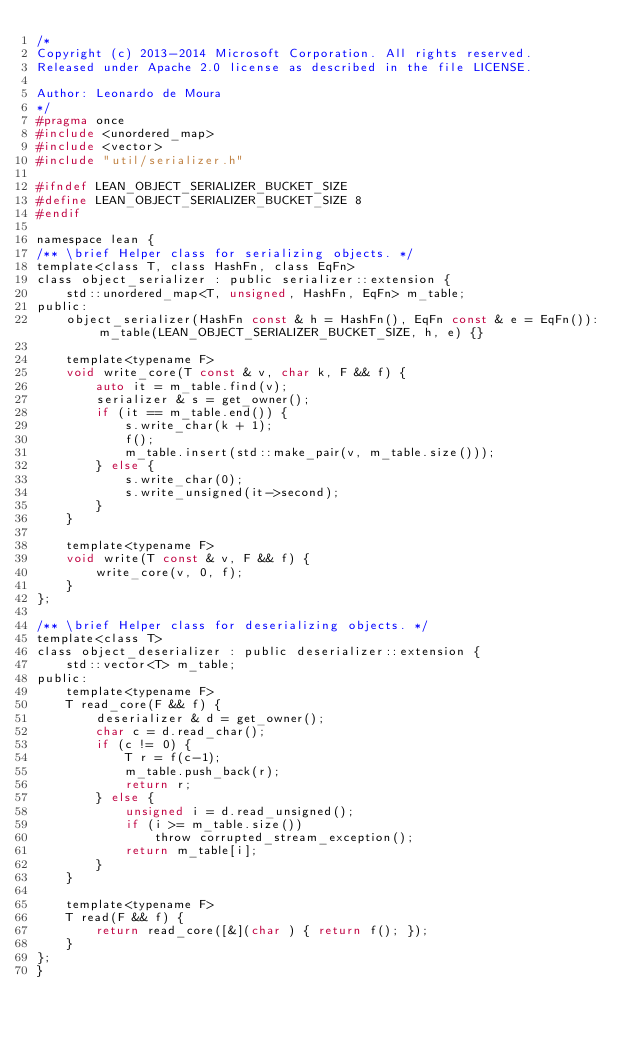Convert code to text. <code><loc_0><loc_0><loc_500><loc_500><_C_>/*
Copyright (c) 2013-2014 Microsoft Corporation. All rights reserved.
Released under Apache 2.0 license as described in the file LICENSE.

Author: Leonardo de Moura
*/
#pragma once
#include <unordered_map>
#include <vector>
#include "util/serializer.h"

#ifndef LEAN_OBJECT_SERIALIZER_BUCKET_SIZE
#define LEAN_OBJECT_SERIALIZER_BUCKET_SIZE 8
#endif

namespace lean {
/** \brief Helper class for serializing objects. */
template<class T, class HashFn, class EqFn>
class object_serializer : public serializer::extension {
    std::unordered_map<T, unsigned, HashFn, EqFn> m_table;
public:
    object_serializer(HashFn const & h = HashFn(), EqFn const & e = EqFn()):m_table(LEAN_OBJECT_SERIALIZER_BUCKET_SIZE, h, e) {}

    template<typename F>
    void write_core(T const & v, char k, F && f) {
        auto it = m_table.find(v);
        serializer & s = get_owner();
        if (it == m_table.end()) {
            s.write_char(k + 1);
            f();
            m_table.insert(std::make_pair(v, m_table.size()));
        } else {
            s.write_char(0);
            s.write_unsigned(it->second);
        }
    }

    template<typename F>
    void write(T const & v, F && f) {
        write_core(v, 0, f);
    }
};

/** \brief Helper class for deserializing objects. */
template<class T>
class object_deserializer : public deserializer::extension {
    std::vector<T> m_table;
public:
    template<typename F>
    T read_core(F && f) {
        deserializer & d = get_owner();
        char c = d.read_char();
        if (c != 0) {
            T r = f(c-1);
            m_table.push_back(r);
            return r;
        } else {
            unsigned i = d.read_unsigned();
            if (i >= m_table.size())
                throw corrupted_stream_exception();
            return m_table[i];
        }
    }

    template<typename F>
    T read(F && f) {
        return read_core([&](char ) { return f(); });
    }
};
}
</code> 